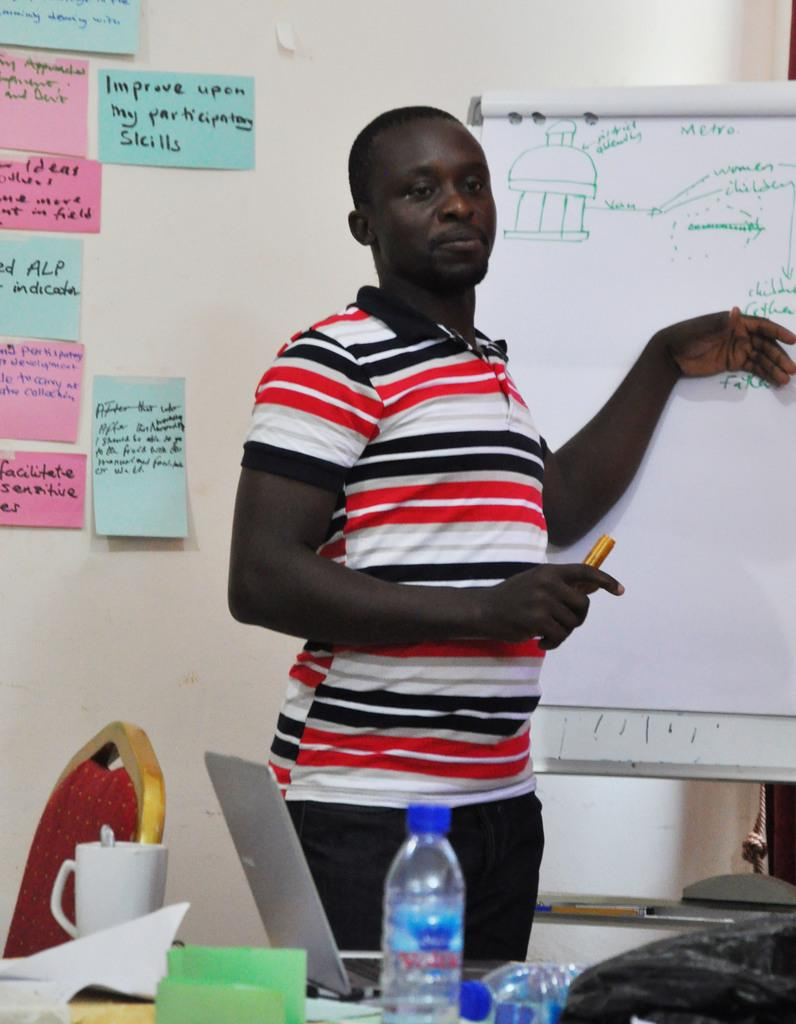Provide a one-sentence caption for the provided image. Man at white board that has a drawing and Metra in green. 